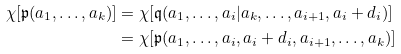<formula> <loc_0><loc_0><loc_500><loc_500>\chi [ \mathfrak { p } ( a _ { 1 } , \dots , a _ { k } ) ] & = \chi [ \mathfrak { q } ( a _ { 1 } , \dots , a _ { i } | a _ { k } , \dots , a _ { i + 1 } , a _ { i } + d _ { i } ) ] \\ & = \chi [ \mathfrak { p } ( a _ { 1 } , \dots , a _ { i } , a _ { i } + d _ { i } , a _ { i + 1 } , \dots , a _ { k } ) ] \\</formula> 